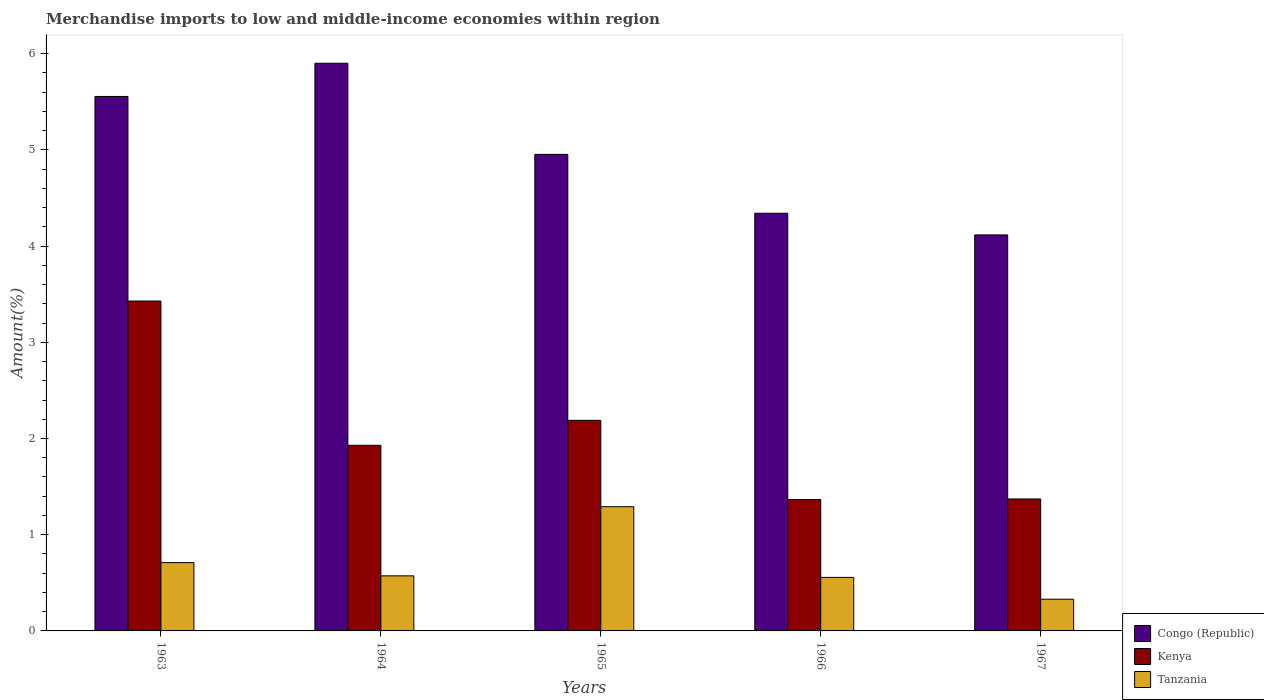How many bars are there on the 4th tick from the left?
Provide a short and direct response. 3. What is the label of the 2nd group of bars from the left?
Your answer should be very brief. 1964. What is the percentage of amount earned from merchandise imports in Congo (Republic) in 1963?
Provide a succinct answer. 5.56. Across all years, what is the maximum percentage of amount earned from merchandise imports in Congo (Republic)?
Your answer should be very brief. 5.9. Across all years, what is the minimum percentage of amount earned from merchandise imports in Tanzania?
Offer a very short reply. 0.33. In which year was the percentage of amount earned from merchandise imports in Kenya maximum?
Keep it short and to the point. 1963. In which year was the percentage of amount earned from merchandise imports in Tanzania minimum?
Offer a terse response. 1967. What is the total percentage of amount earned from merchandise imports in Kenya in the graph?
Offer a terse response. 10.28. What is the difference between the percentage of amount earned from merchandise imports in Kenya in 1964 and that in 1967?
Ensure brevity in your answer.  0.56. What is the difference between the percentage of amount earned from merchandise imports in Tanzania in 1965 and the percentage of amount earned from merchandise imports in Kenya in 1967?
Make the answer very short. -0.08. What is the average percentage of amount earned from merchandise imports in Tanzania per year?
Offer a very short reply. 0.69. In the year 1967, what is the difference between the percentage of amount earned from merchandise imports in Kenya and percentage of amount earned from merchandise imports in Congo (Republic)?
Your answer should be very brief. -2.74. In how many years, is the percentage of amount earned from merchandise imports in Kenya greater than 1.4 %?
Provide a short and direct response. 3. What is the ratio of the percentage of amount earned from merchandise imports in Kenya in 1965 to that in 1966?
Your response must be concise. 1.6. Is the difference between the percentage of amount earned from merchandise imports in Kenya in 1963 and 1967 greater than the difference between the percentage of amount earned from merchandise imports in Congo (Republic) in 1963 and 1967?
Ensure brevity in your answer.  Yes. What is the difference between the highest and the second highest percentage of amount earned from merchandise imports in Tanzania?
Give a very brief answer. 0.58. What is the difference between the highest and the lowest percentage of amount earned from merchandise imports in Congo (Republic)?
Your answer should be compact. 1.78. Is the sum of the percentage of amount earned from merchandise imports in Congo (Republic) in 1964 and 1967 greater than the maximum percentage of amount earned from merchandise imports in Tanzania across all years?
Provide a succinct answer. Yes. What does the 3rd bar from the left in 1967 represents?
Offer a terse response. Tanzania. What does the 2nd bar from the right in 1966 represents?
Make the answer very short. Kenya. Is it the case that in every year, the sum of the percentage of amount earned from merchandise imports in Tanzania and percentage of amount earned from merchandise imports in Kenya is greater than the percentage of amount earned from merchandise imports in Congo (Republic)?
Offer a terse response. No. Are all the bars in the graph horizontal?
Give a very brief answer. No. How many years are there in the graph?
Ensure brevity in your answer.  5. What is the difference between two consecutive major ticks on the Y-axis?
Provide a short and direct response. 1. Does the graph contain any zero values?
Make the answer very short. No. Does the graph contain grids?
Your response must be concise. No. Where does the legend appear in the graph?
Your answer should be very brief. Bottom right. How many legend labels are there?
Ensure brevity in your answer.  3. What is the title of the graph?
Your answer should be compact. Merchandise imports to low and middle-income economies within region. Does "Tonga" appear as one of the legend labels in the graph?
Make the answer very short. No. What is the label or title of the Y-axis?
Provide a short and direct response. Amount(%). What is the Amount(%) of Congo (Republic) in 1963?
Provide a short and direct response. 5.56. What is the Amount(%) of Kenya in 1963?
Your answer should be compact. 3.43. What is the Amount(%) in Tanzania in 1963?
Keep it short and to the point. 0.71. What is the Amount(%) in Congo (Republic) in 1964?
Offer a terse response. 5.9. What is the Amount(%) of Kenya in 1964?
Offer a terse response. 1.93. What is the Amount(%) of Tanzania in 1964?
Give a very brief answer. 0.57. What is the Amount(%) in Congo (Republic) in 1965?
Make the answer very short. 4.95. What is the Amount(%) in Kenya in 1965?
Keep it short and to the point. 2.19. What is the Amount(%) of Tanzania in 1965?
Ensure brevity in your answer.  1.29. What is the Amount(%) in Congo (Republic) in 1966?
Offer a terse response. 4.34. What is the Amount(%) of Kenya in 1966?
Ensure brevity in your answer.  1.37. What is the Amount(%) in Tanzania in 1966?
Your response must be concise. 0.56. What is the Amount(%) in Congo (Republic) in 1967?
Give a very brief answer. 4.12. What is the Amount(%) of Kenya in 1967?
Provide a short and direct response. 1.37. What is the Amount(%) of Tanzania in 1967?
Provide a short and direct response. 0.33. Across all years, what is the maximum Amount(%) in Congo (Republic)?
Provide a succinct answer. 5.9. Across all years, what is the maximum Amount(%) of Kenya?
Keep it short and to the point. 3.43. Across all years, what is the maximum Amount(%) of Tanzania?
Your answer should be very brief. 1.29. Across all years, what is the minimum Amount(%) in Congo (Republic)?
Give a very brief answer. 4.12. Across all years, what is the minimum Amount(%) in Kenya?
Your answer should be compact. 1.37. Across all years, what is the minimum Amount(%) of Tanzania?
Give a very brief answer. 0.33. What is the total Amount(%) of Congo (Republic) in the graph?
Keep it short and to the point. 24.87. What is the total Amount(%) of Kenya in the graph?
Provide a succinct answer. 10.28. What is the total Amount(%) in Tanzania in the graph?
Ensure brevity in your answer.  3.46. What is the difference between the Amount(%) of Congo (Republic) in 1963 and that in 1964?
Give a very brief answer. -0.35. What is the difference between the Amount(%) in Kenya in 1963 and that in 1964?
Your answer should be compact. 1.5. What is the difference between the Amount(%) of Tanzania in 1963 and that in 1964?
Your answer should be compact. 0.14. What is the difference between the Amount(%) in Congo (Republic) in 1963 and that in 1965?
Your response must be concise. 0.6. What is the difference between the Amount(%) of Kenya in 1963 and that in 1965?
Your answer should be compact. 1.24. What is the difference between the Amount(%) in Tanzania in 1963 and that in 1965?
Make the answer very short. -0.58. What is the difference between the Amount(%) in Congo (Republic) in 1963 and that in 1966?
Your answer should be compact. 1.21. What is the difference between the Amount(%) in Kenya in 1963 and that in 1966?
Your answer should be compact. 2.06. What is the difference between the Amount(%) in Tanzania in 1963 and that in 1966?
Provide a succinct answer. 0.15. What is the difference between the Amount(%) of Congo (Republic) in 1963 and that in 1967?
Provide a short and direct response. 1.44. What is the difference between the Amount(%) in Kenya in 1963 and that in 1967?
Your answer should be compact. 2.06. What is the difference between the Amount(%) of Tanzania in 1963 and that in 1967?
Ensure brevity in your answer.  0.38. What is the difference between the Amount(%) of Congo (Republic) in 1964 and that in 1965?
Give a very brief answer. 0.95. What is the difference between the Amount(%) in Kenya in 1964 and that in 1965?
Provide a succinct answer. -0.26. What is the difference between the Amount(%) in Tanzania in 1964 and that in 1965?
Ensure brevity in your answer.  -0.72. What is the difference between the Amount(%) in Congo (Republic) in 1964 and that in 1966?
Make the answer very short. 1.56. What is the difference between the Amount(%) in Kenya in 1964 and that in 1966?
Make the answer very short. 0.56. What is the difference between the Amount(%) in Tanzania in 1964 and that in 1966?
Offer a very short reply. 0.02. What is the difference between the Amount(%) of Congo (Republic) in 1964 and that in 1967?
Ensure brevity in your answer.  1.78. What is the difference between the Amount(%) of Kenya in 1964 and that in 1967?
Give a very brief answer. 0.56. What is the difference between the Amount(%) in Tanzania in 1964 and that in 1967?
Offer a very short reply. 0.24. What is the difference between the Amount(%) of Congo (Republic) in 1965 and that in 1966?
Your answer should be very brief. 0.61. What is the difference between the Amount(%) of Kenya in 1965 and that in 1966?
Ensure brevity in your answer.  0.82. What is the difference between the Amount(%) in Tanzania in 1965 and that in 1966?
Offer a very short reply. 0.73. What is the difference between the Amount(%) in Congo (Republic) in 1965 and that in 1967?
Offer a very short reply. 0.84. What is the difference between the Amount(%) in Kenya in 1965 and that in 1967?
Offer a terse response. 0.82. What is the difference between the Amount(%) in Tanzania in 1965 and that in 1967?
Give a very brief answer. 0.96. What is the difference between the Amount(%) in Congo (Republic) in 1966 and that in 1967?
Give a very brief answer. 0.23. What is the difference between the Amount(%) of Kenya in 1966 and that in 1967?
Your answer should be compact. -0.01. What is the difference between the Amount(%) in Tanzania in 1966 and that in 1967?
Your response must be concise. 0.23. What is the difference between the Amount(%) of Congo (Republic) in 1963 and the Amount(%) of Kenya in 1964?
Your answer should be very brief. 3.63. What is the difference between the Amount(%) in Congo (Republic) in 1963 and the Amount(%) in Tanzania in 1964?
Provide a succinct answer. 4.98. What is the difference between the Amount(%) of Kenya in 1963 and the Amount(%) of Tanzania in 1964?
Ensure brevity in your answer.  2.86. What is the difference between the Amount(%) in Congo (Republic) in 1963 and the Amount(%) in Kenya in 1965?
Make the answer very short. 3.37. What is the difference between the Amount(%) of Congo (Republic) in 1963 and the Amount(%) of Tanzania in 1965?
Give a very brief answer. 4.26. What is the difference between the Amount(%) of Kenya in 1963 and the Amount(%) of Tanzania in 1965?
Ensure brevity in your answer.  2.14. What is the difference between the Amount(%) of Congo (Republic) in 1963 and the Amount(%) of Kenya in 1966?
Provide a succinct answer. 4.19. What is the difference between the Amount(%) in Congo (Republic) in 1963 and the Amount(%) in Tanzania in 1966?
Your answer should be very brief. 5. What is the difference between the Amount(%) in Kenya in 1963 and the Amount(%) in Tanzania in 1966?
Offer a terse response. 2.87. What is the difference between the Amount(%) of Congo (Republic) in 1963 and the Amount(%) of Kenya in 1967?
Offer a terse response. 4.18. What is the difference between the Amount(%) in Congo (Republic) in 1963 and the Amount(%) in Tanzania in 1967?
Your answer should be very brief. 5.23. What is the difference between the Amount(%) in Kenya in 1963 and the Amount(%) in Tanzania in 1967?
Provide a short and direct response. 3.1. What is the difference between the Amount(%) in Congo (Republic) in 1964 and the Amount(%) in Kenya in 1965?
Make the answer very short. 3.71. What is the difference between the Amount(%) in Congo (Republic) in 1964 and the Amount(%) in Tanzania in 1965?
Offer a very short reply. 4.61. What is the difference between the Amount(%) in Kenya in 1964 and the Amount(%) in Tanzania in 1965?
Give a very brief answer. 0.64. What is the difference between the Amount(%) of Congo (Republic) in 1964 and the Amount(%) of Kenya in 1966?
Offer a very short reply. 4.53. What is the difference between the Amount(%) in Congo (Republic) in 1964 and the Amount(%) in Tanzania in 1966?
Make the answer very short. 5.34. What is the difference between the Amount(%) in Kenya in 1964 and the Amount(%) in Tanzania in 1966?
Keep it short and to the point. 1.37. What is the difference between the Amount(%) of Congo (Republic) in 1964 and the Amount(%) of Kenya in 1967?
Keep it short and to the point. 4.53. What is the difference between the Amount(%) in Congo (Republic) in 1964 and the Amount(%) in Tanzania in 1967?
Provide a succinct answer. 5.57. What is the difference between the Amount(%) in Kenya in 1964 and the Amount(%) in Tanzania in 1967?
Keep it short and to the point. 1.6. What is the difference between the Amount(%) in Congo (Republic) in 1965 and the Amount(%) in Kenya in 1966?
Your response must be concise. 3.59. What is the difference between the Amount(%) in Congo (Republic) in 1965 and the Amount(%) in Tanzania in 1966?
Offer a very short reply. 4.4. What is the difference between the Amount(%) in Kenya in 1965 and the Amount(%) in Tanzania in 1966?
Make the answer very short. 1.63. What is the difference between the Amount(%) in Congo (Republic) in 1965 and the Amount(%) in Kenya in 1967?
Your answer should be very brief. 3.58. What is the difference between the Amount(%) in Congo (Republic) in 1965 and the Amount(%) in Tanzania in 1967?
Your response must be concise. 4.62. What is the difference between the Amount(%) in Kenya in 1965 and the Amount(%) in Tanzania in 1967?
Make the answer very short. 1.86. What is the difference between the Amount(%) of Congo (Republic) in 1966 and the Amount(%) of Kenya in 1967?
Give a very brief answer. 2.97. What is the difference between the Amount(%) of Congo (Republic) in 1966 and the Amount(%) of Tanzania in 1967?
Make the answer very short. 4.01. What is the difference between the Amount(%) of Kenya in 1966 and the Amount(%) of Tanzania in 1967?
Ensure brevity in your answer.  1.04. What is the average Amount(%) of Congo (Republic) per year?
Your response must be concise. 4.97. What is the average Amount(%) in Kenya per year?
Provide a short and direct response. 2.06. What is the average Amount(%) of Tanzania per year?
Your answer should be compact. 0.69. In the year 1963, what is the difference between the Amount(%) in Congo (Republic) and Amount(%) in Kenya?
Keep it short and to the point. 2.13. In the year 1963, what is the difference between the Amount(%) in Congo (Republic) and Amount(%) in Tanzania?
Provide a short and direct response. 4.85. In the year 1963, what is the difference between the Amount(%) in Kenya and Amount(%) in Tanzania?
Give a very brief answer. 2.72. In the year 1964, what is the difference between the Amount(%) of Congo (Republic) and Amount(%) of Kenya?
Keep it short and to the point. 3.97. In the year 1964, what is the difference between the Amount(%) of Congo (Republic) and Amount(%) of Tanzania?
Your answer should be very brief. 5.33. In the year 1964, what is the difference between the Amount(%) in Kenya and Amount(%) in Tanzania?
Provide a succinct answer. 1.36. In the year 1965, what is the difference between the Amount(%) in Congo (Republic) and Amount(%) in Kenya?
Give a very brief answer. 2.76. In the year 1965, what is the difference between the Amount(%) of Congo (Republic) and Amount(%) of Tanzania?
Your response must be concise. 3.66. In the year 1965, what is the difference between the Amount(%) of Kenya and Amount(%) of Tanzania?
Keep it short and to the point. 0.9. In the year 1966, what is the difference between the Amount(%) of Congo (Republic) and Amount(%) of Kenya?
Your response must be concise. 2.98. In the year 1966, what is the difference between the Amount(%) in Congo (Republic) and Amount(%) in Tanzania?
Ensure brevity in your answer.  3.79. In the year 1966, what is the difference between the Amount(%) of Kenya and Amount(%) of Tanzania?
Ensure brevity in your answer.  0.81. In the year 1967, what is the difference between the Amount(%) in Congo (Republic) and Amount(%) in Kenya?
Your answer should be compact. 2.74. In the year 1967, what is the difference between the Amount(%) in Congo (Republic) and Amount(%) in Tanzania?
Make the answer very short. 3.79. In the year 1967, what is the difference between the Amount(%) of Kenya and Amount(%) of Tanzania?
Your answer should be compact. 1.04. What is the ratio of the Amount(%) of Congo (Republic) in 1963 to that in 1964?
Provide a short and direct response. 0.94. What is the ratio of the Amount(%) in Kenya in 1963 to that in 1964?
Your response must be concise. 1.78. What is the ratio of the Amount(%) in Tanzania in 1963 to that in 1964?
Your answer should be compact. 1.24. What is the ratio of the Amount(%) of Congo (Republic) in 1963 to that in 1965?
Provide a short and direct response. 1.12. What is the ratio of the Amount(%) of Kenya in 1963 to that in 1965?
Make the answer very short. 1.57. What is the ratio of the Amount(%) of Tanzania in 1963 to that in 1965?
Your answer should be compact. 0.55. What is the ratio of the Amount(%) in Congo (Republic) in 1963 to that in 1966?
Give a very brief answer. 1.28. What is the ratio of the Amount(%) of Kenya in 1963 to that in 1966?
Offer a very short reply. 2.51. What is the ratio of the Amount(%) in Tanzania in 1963 to that in 1966?
Your answer should be very brief. 1.28. What is the ratio of the Amount(%) in Congo (Republic) in 1963 to that in 1967?
Offer a terse response. 1.35. What is the ratio of the Amount(%) of Kenya in 1963 to that in 1967?
Provide a short and direct response. 2.5. What is the ratio of the Amount(%) of Tanzania in 1963 to that in 1967?
Offer a terse response. 2.15. What is the ratio of the Amount(%) in Congo (Republic) in 1964 to that in 1965?
Keep it short and to the point. 1.19. What is the ratio of the Amount(%) in Kenya in 1964 to that in 1965?
Keep it short and to the point. 0.88. What is the ratio of the Amount(%) of Tanzania in 1964 to that in 1965?
Your response must be concise. 0.44. What is the ratio of the Amount(%) in Congo (Republic) in 1964 to that in 1966?
Offer a terse response. 1.36. What is the ratio of the Amount(%) in Kenya in 1964 to that in 1966?
Your answer should be compact. 1.41. What is the ratio of the Amount(%) in Tanzania in 1964 to that in 1966?
Give a very brief answer. 1.03. What is the ratio of the Amount(%) of Congo (Republic) in 1964 to that in 1967?
Keep it short and to the point. 1.43. What is the ratio of the Amount(%) in Kenya in 1964 to that in 1967?
Provide a short and direct response. 1.41. What is the ratio of the Amount(%) in Tanzania in 1964 to that in 1967?
Your response must be concise. 1.74. What is the ratio of the Amount(%) of Congo (Republic) in 1965 to that in 1966?
Ensure brevity in your answer.  1.14. What is the ratio of the Amount(%) of Kenya in 1965 to that in 1966?
Make the answer very short. 1.6. What is the ratio of the Amount(%) of Tanzania in 1965 to that in 1966?
Your response must be concise. 2.32. What is the ratio of the Amount(%) of Congo (Republic) in 1965 to that in 1967?
Make the answer very short. 1.2. What is the ratio of the Amount(%) in Kenya in 1965 to that in 1967?
Provide a short and direct response. 1.6. What is the ratio of the Amount(%) in Tanzania in 1965 to that in 1967?
Provide a short and direct response. 3.91. What is the ratio of the Amount(%) in Congo (Republic) in 1966 to that in 1967?
Your answer should be very brief. 1.05. What is the ratio of the Amount(%) of Kenya in 1966 to that in 1967?
Provide a short and direct response. 1. What is the ratio of the Amount(%) of Tanzania in 1966 to that in 1967?
Offer a very short reply. 1.69. What is the difference between the highest and the second highest Amount(%) of Congo (Republic)?
Offer a very short reply. 0.35. What is the difference between the highest and the second highest Amount(%) in Kenya?
Ensure brevity in your answer.  1.24. What is the difference between the highest and the second highest Amount(%) of Tanzania?
Make the answer very short. 0.58. What is the difference between the highest and the lowest Amount(%) of Congo (Republic)?
Offer a very short reply. 1.78. What is the difference between the highest and the lowest Amount(%) of Kenya?
Offer a terse response. 2.06. What is the difference between the highest and the lowest Amount(%) in Tanzania?
Make the answer very short. 0.96. 